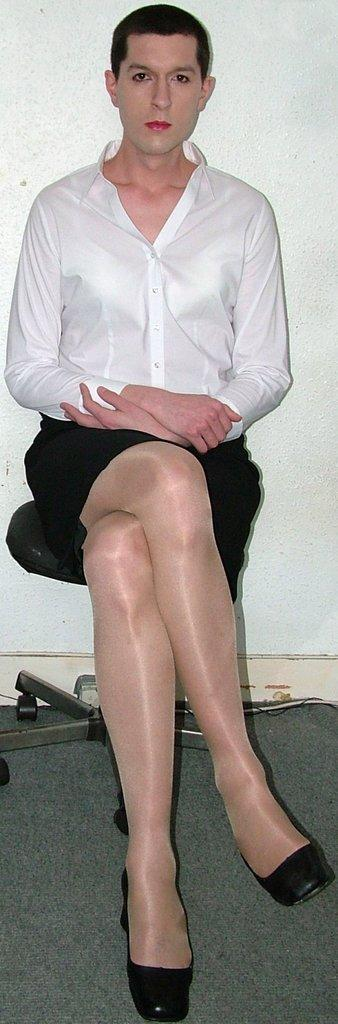What is the person in the image doing? The person is sitting on a chair in the image. What can be seen behind the person? There is a wall visible in the image. What type of church is visible in the image? There is no church present in the image; it only features a person sitting on a chair and a wall. 